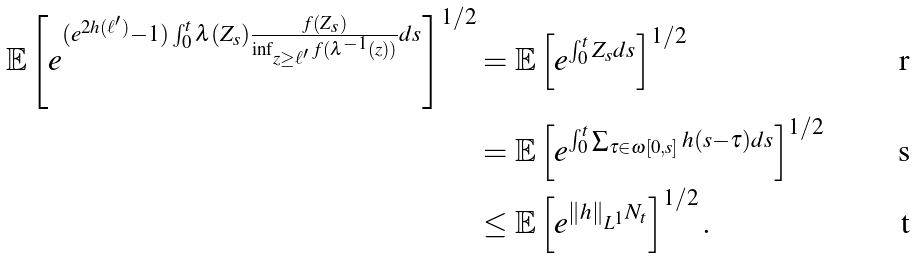<formula> <loc_0><loc_0><loc_500><loc_500>\mathbb { E } \left [ e ^ { ( e ^ { 2 h ( \ell ^ { \prime } ) } - 1 ) \int _ { 0 } ^ { t } \lambda ( Z _ { s } ) \frac { f ( Z _ { s } ) } { \inf _ { z \geq \ell ^ { \prime } } f ( \lambda ^ { - 1 } ( z ) ) } d s } \right ] ^ { 1 / 2 } & = \mathbb { E } \left [ e ^ { \int _ { 0 } ^ { t } Z _ { s } d s } \right ] ^ { 1 / 2 } \\ & = \mathbb { E } \left [ e ^ { \int _ { 0 } ^ { t } \sum _ { \tau \in \omega [ 0 , s ] } h ( s - \tau ) d s } \right ] ^ { 1 / 2 } \\ & \leq \mathbb { E } \left [ e ^ { \| h \| _ { L ^ { 1 } } N _ { t } } \right ] ^ { 1 / 2 } .</formula> 